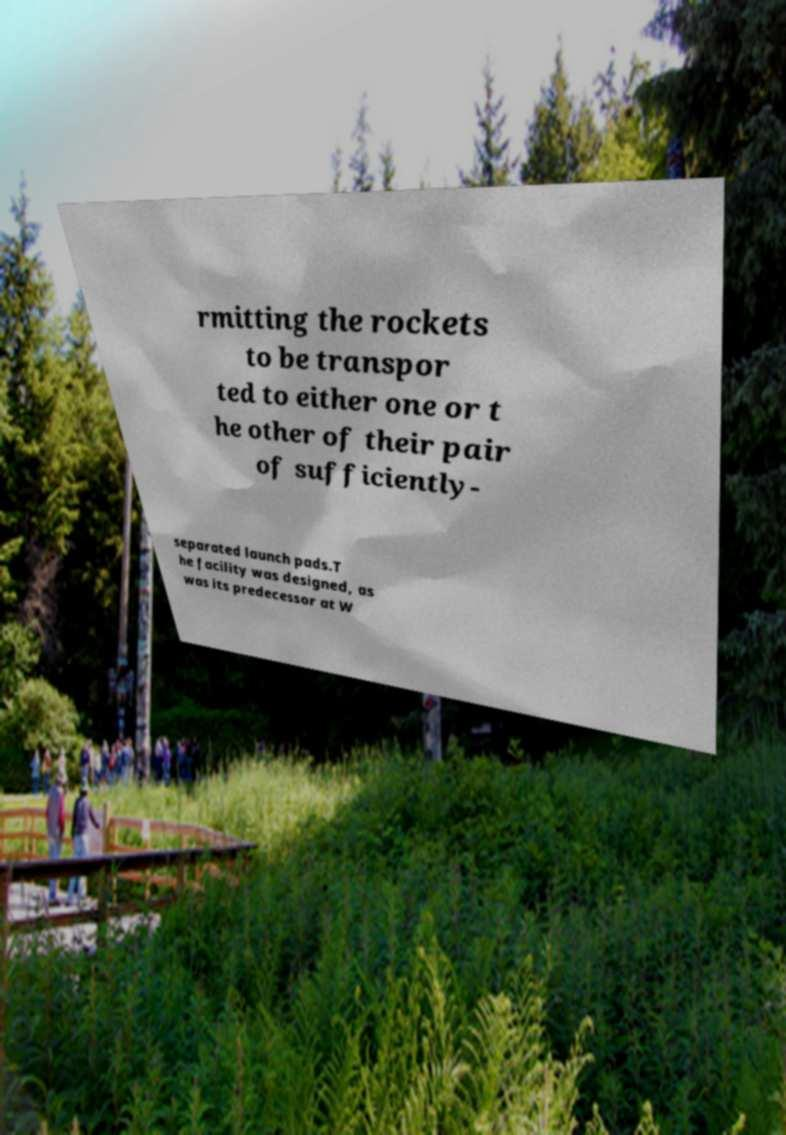Can you accurately transcribe the text from the provided image for me? rmitting the rockets to be transpor ted to either one or t he other of their pair of sufficiently- separated launch pads.T he facility was designed, as was its predecessor at W 